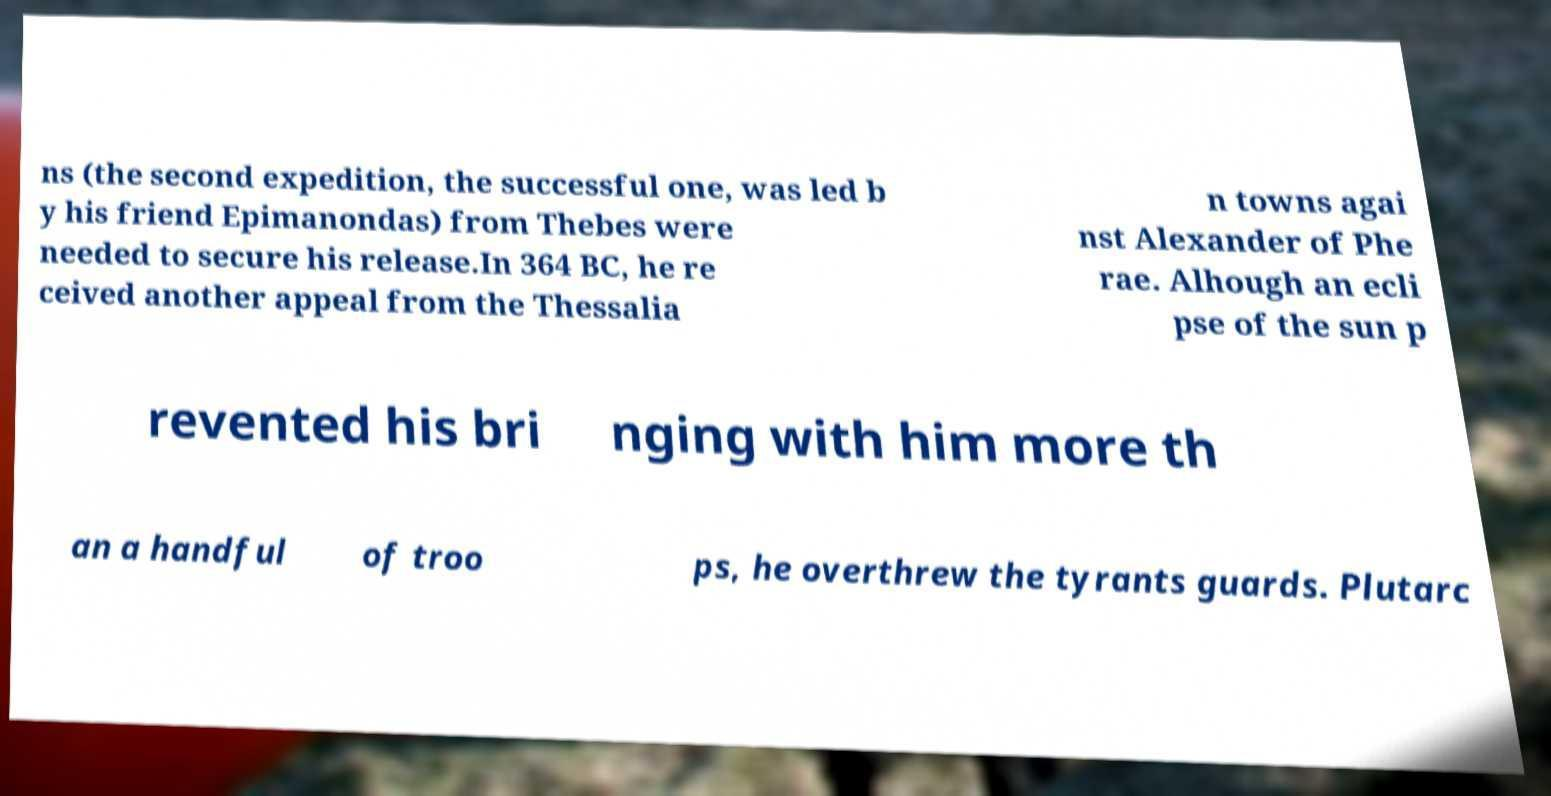Can you read and provide the text displayed in the image?This photo seems to have some interesting text. Can you extract and type it out for me? ns (the second expedition, the successful one, was led b y his friend Epimanondas) from Thebes were needed to secure his release.In 364 BC, he re ceived another appeal from the Thessalia n towns agai nst Alexander of Phe rae. Alhough an ecli pse of the sun p revented his bri nging with him more th an a handful of troo ps, he overthrew the tyrants guards. Plutarc 